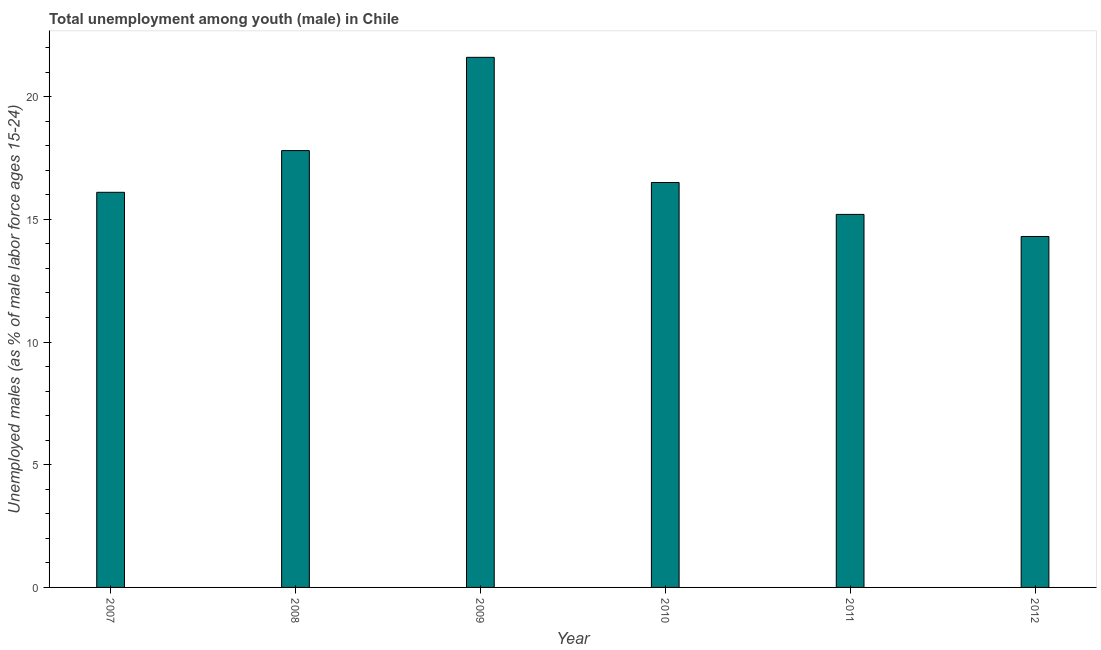Does the graph contain any zero values?
Ensure brevity in your answer.  No. Does the graph contain grids?
Offer a terse response. No. What is the title of the graph?
Offer a very short reply. Total unemployment among youth (male) in Chile. What is the label or title of the Y-axis?
Make the answer very short. Unemployed males (as % of male labor force ages 15-24). What is the unemployed male youth population in 2009?
Ensure brevity in your answer.  21.6. Across all years, what is the maximum unemployed male youth population?
Your response must be concise. 21.6. Across all years, what is the minimum unemployed male youth population?
Offer a terse response. 14.3. What is the sum of the unemployed male youth population?
Provide a succinct answer. 101.5. What is the difference between the unemployed male youth population in 2011 and 2012?
Offer a terse response. 0.9. What is the average unemployed male youth population per year?
Keep it short and to the point. 16.92. What is the median unemployed male youth population?
Give a very brief answer. 16.3. What is the ratio of the unemployed male youth population in 2008 to that in 2012?
Give a very brief answer. 1.25. Is the unemployed male youth population in 2008 less than that in 2012?
Offer a terse response. No. Is the sum of the unemployed male youth population in 2007 and 2010 greater than the maximum unemployed male youth population across all years?
Your answer should be compact. Yes. What is the difference between the highest and the lowest unemployed male youth population?
Keep it short and to the point. 7.3. In how many years, is the unemployed male youth population greater than the average unemployed male youth population taken over all years?
Provide a short and direct response. 2. Are all the bars in the graph horizontal?
Make the answer very short. No. How many years are there in the graph?
Give a very brief answer. 6. What is the Unemployed males (as % of male labor force ages 15-24) of 2007?
Provide a succinct answer. 16.1. What is the Unemployed males (as % of male labor force ages 15-24) of 2008?
Make the answer very short. 17.8. What is the Unemployed males (as % of male labor force ages 15-24) in 2009?
Offer a terse response. 21.6. What is the Unemployed males (as % of male labor force ages 15-24) in 2010?
Provide a succinct answer. 16.5. What is the Unemployed males (as % of male labor force ages 15-24) in 2011?
Keep it short and to the point. 15.2. What is the Unemployed males (as % of male labor force ages 15-24) in 2012?
Your answer should be compact. 14.3. What is the difference between the Unemployed males (as % of male labor force ages 15-24) in 2007 and 2009?
Your response must be concise. -5.5. What is the difference between the Unemployed males (as % of male labor force ages 15-24) in 2007 and 2010?
Make the answer very short. -0.4. What is the difference between the Unemployed males (as % of male labor force ages 15-24) in 2007 and 2011?
Your answer should be compact. 0.9. What is the difference between the Unemployed males (as % of male labor force ages 15-24) in 2007 and 2012?
Keep it short and to the point. 1.8. What is the difference between the Unemployed males (as % of male labor force ages 15-24) in 2008 and 2010?
Give a very brief answer. 1.3. What is the difference between the Unemployed males (as % of male labor force ages 15-24) in 2008 and 2011?
Keep it short and to the point. 2.6. What is the difference between the Unemployed males (as % of male labor force ages 15-24) in 2009 and 2012?
Offer a very short reply. 7.3. What is the ratio of the Unemployed males (as % of male labor force ages 15-24) in 2007 to that in 2008?
Keep it short and to the point. 0.9. What is the ratio of the Unemployed males (as % of male labor force ages 15-24) in 2007 to that in 2009?
Keep it short and to the point. 0.74. What is the ratio of the Unemployed males (as % of male labor force ages 15-24) in 2007 to that in 2011?
Your answer should be compact. 1.06. What is the ratio of the Unemployed males (as % of male labor force ages 15-24) in 2007 to that in 2012?
Provide a short and direct response. 1.13. What is the ratio of the Unemployed males (as % of male labor force ages 15-24) in 2008 to that in 2009?
Offer a very short reply. 0.82. What is the ratio of the Unemployed males (as % of male labor force ages 15-24) in 2008 to that in 2010?
Give a very brief answer. 1.08. What is the ratio of the Unemployed males (as % of male labor force ages 15-24) in 2008 to that in 2011?
Your response must be concise. 1.17. What is the ratio of the Unemployed males (as % of male labor force ages 15-24) in 2008 to that in 2012?
Provide a succinct answer. 1.25. What is the ratio of the Unemployed males (as % of male labor force ages 15-24) in 2009 to that in 2010?
Your answer should be compact. 1.31. What is the ratio of the Unemployed males (as % of male labor force ages 15-24) in 2009 to that in 2011?
Your response must be concise. 1.42. What is the ratio of the Unemployed males (as % of male labor force ages 15-24) in 2009 to that in 2012?
Offer a very short reply. 1.51. What is the ratio of the Unemployed males (as % of male labor force ages 15-24) in 2010 to that in 2011?
Provide a succinct answer. 1.09. What is the ratio of the Unemployed males (as % of male labor force ages 15-24) in 2010 to that in 2012?
Offer a terse response. 1.15. What is the ratio of the Unemployed males (as % of male labor force ages 15-24) in 2011 to that in 2012?
Your answer should be very brief. 1.06. 